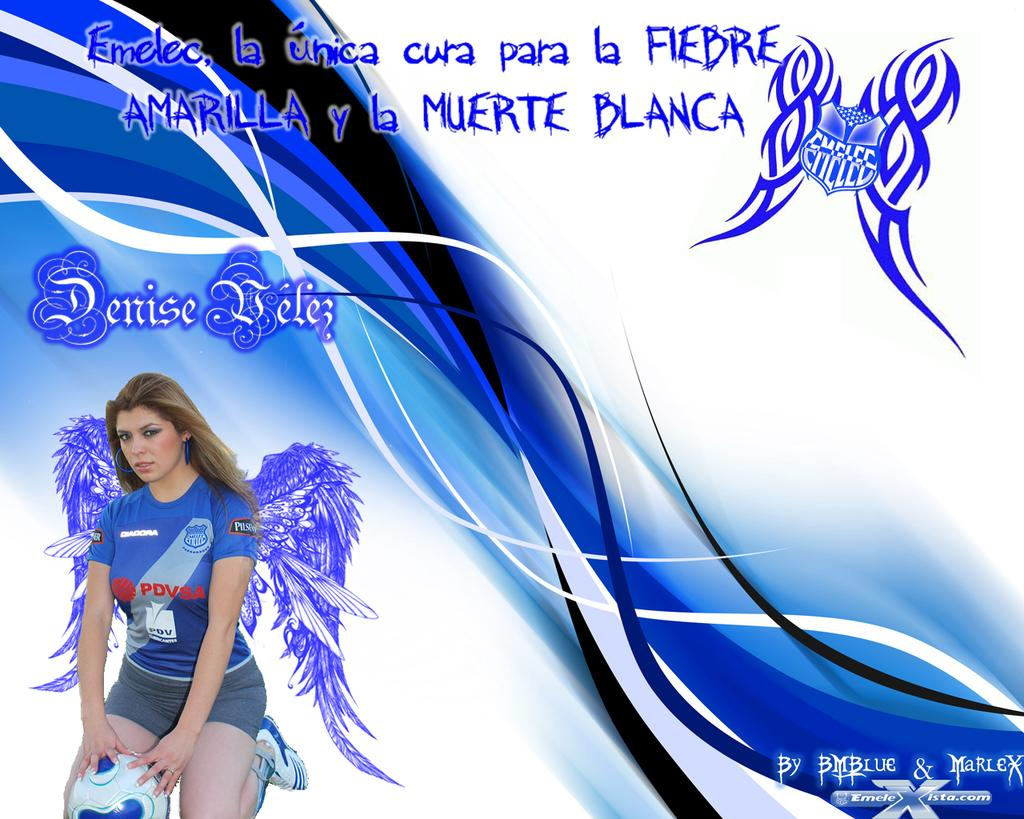<image>
Give a short and clear explanation of the subsequent image. the word blanca that is near some lady 